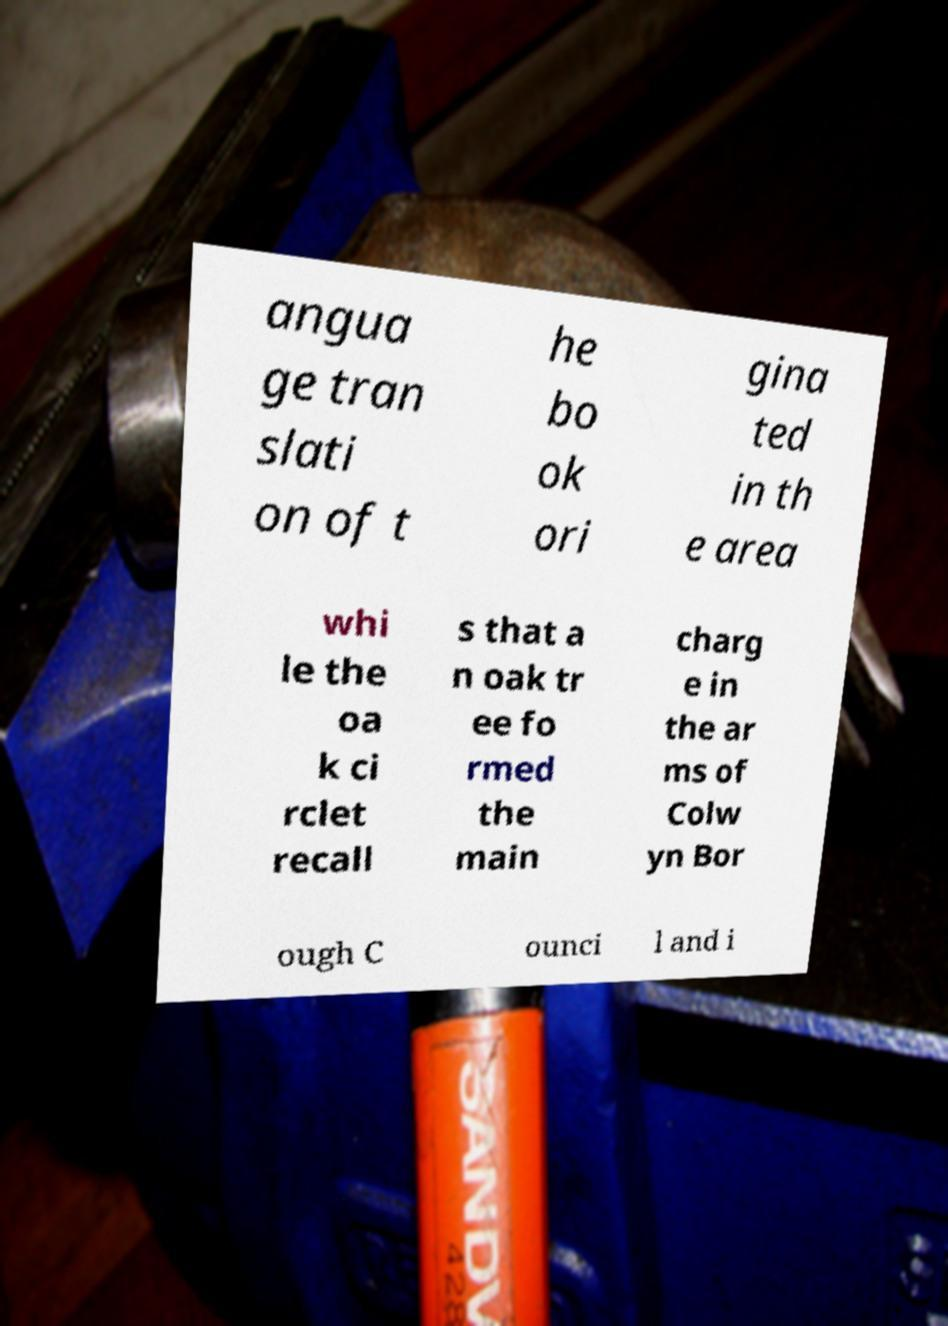Could you extract and type out the text from this image? angua ge tran slati on of t he bo ok ori gina ted in th e area whi le the oa k ci rclet recall s that a n oak tr ee fo rmed the main charg e in the ar ms of Colw yn Bor ough C ounci l and i 